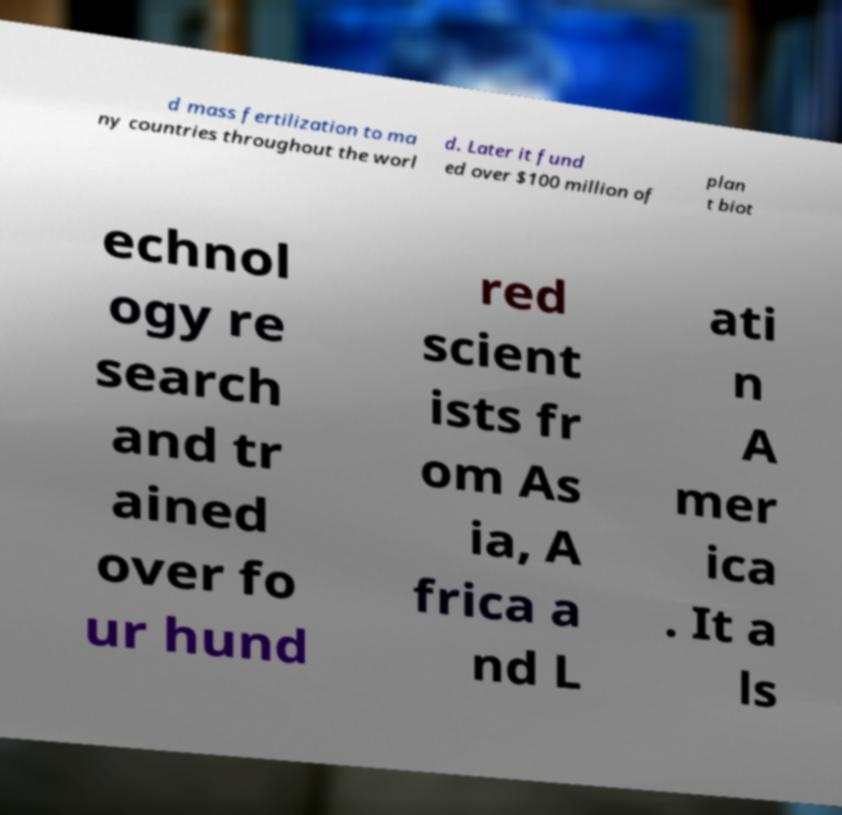Please read and relay the text visible in this image. What does it say? d mass fertilization to ma ny countries throughout the worl d. Later it fund ed over $100 million of plan t biot echnol ogy re search and tr ained over fo ur hund red scient ists fr om As ia, A frica a nd L ati n A mer ica . It a ls 